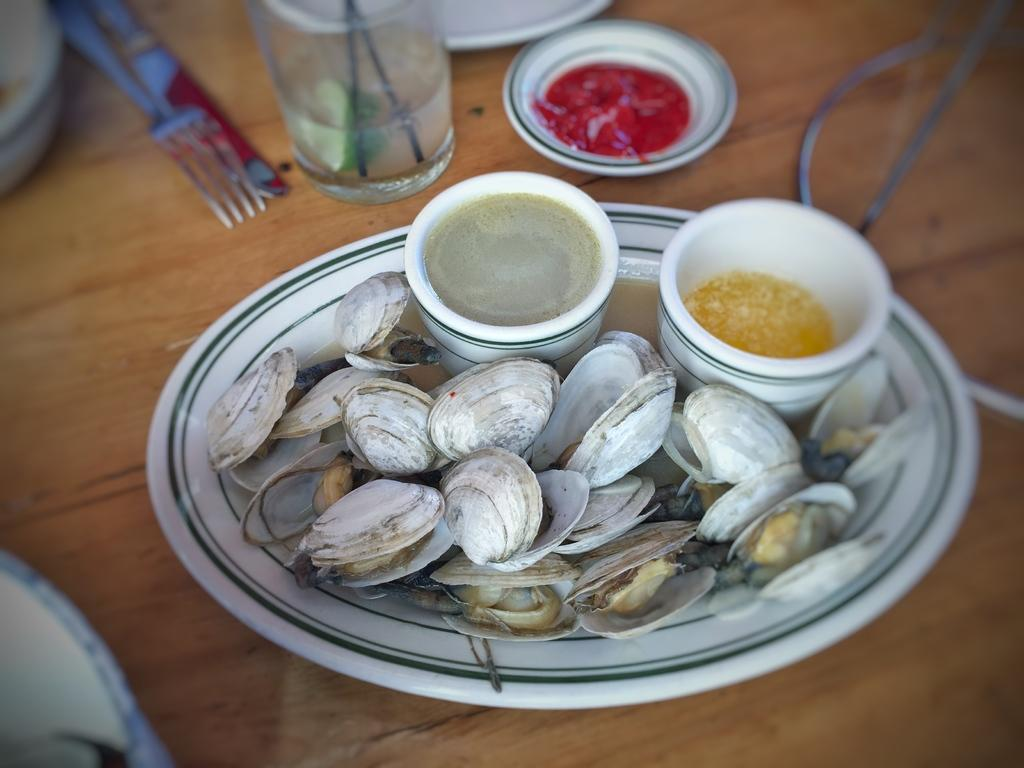What type of objects can be seen in the image? There are shells, a plate with sauces, a glass, red sauce, a fork, and a knife in the image. Where are these objects located? The plate, glass, red sauce, fork, and knife are on a table in the image. What type of utensils are present in the image? There is a fork and a knife in the image. What color is the sauce on the plate? The sauce on the plate is red. Can you tell me who is telling a joke in the image? There is no person present in the image, so it is not possible to determine who might be telling a joke. 